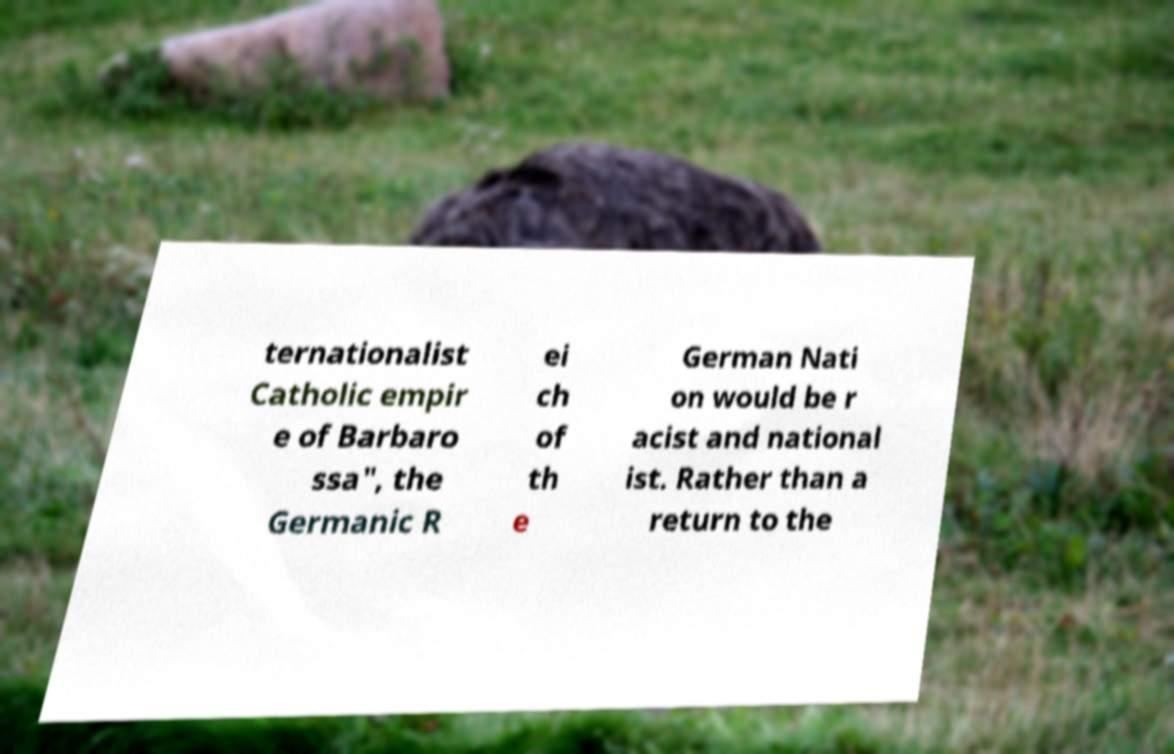I need the written content from this picture converted into text. Can you do that? ternationalist Catholic empir e of Barbaro ssa", the Germanic R ei ch of th e German Nati on would be r acist and national ist. Rather than a return to the 